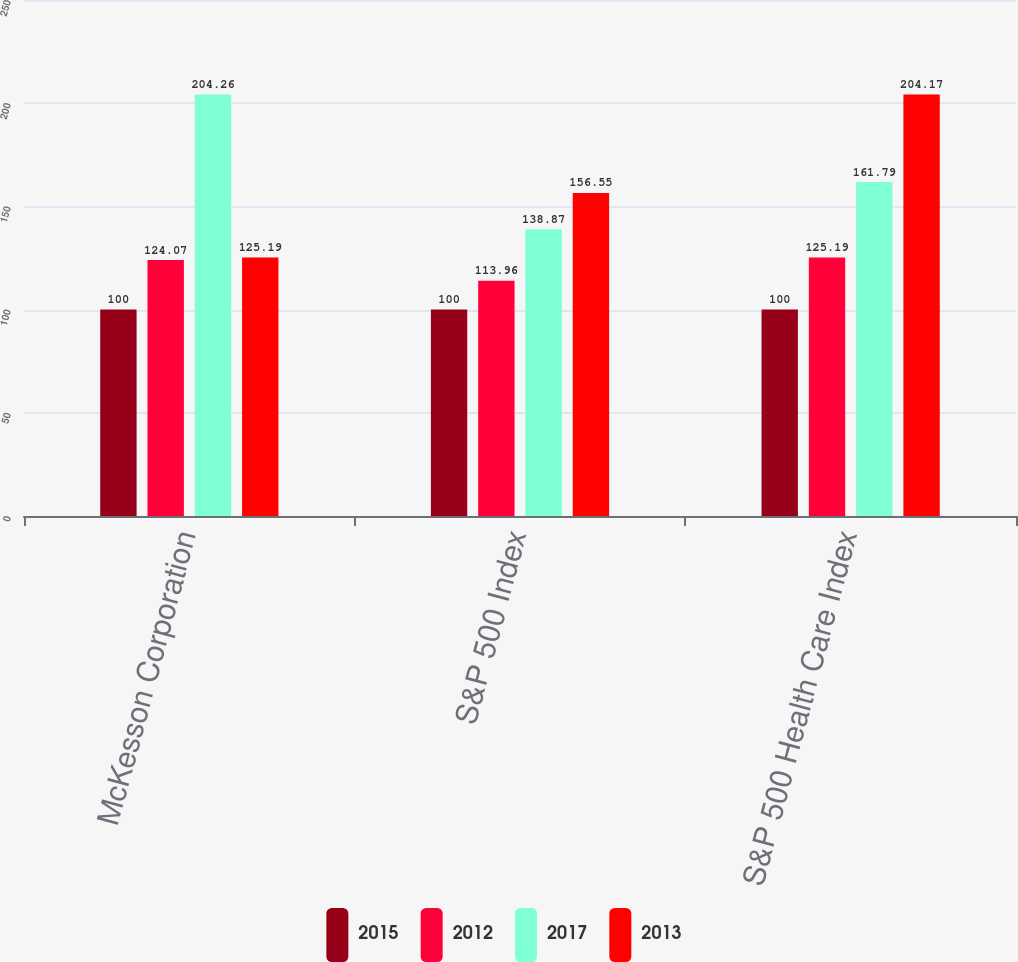<chart> <loc_0><loc_0><loc_500><loc_500><stacked_bar_chart><ecel><fcel>McKesson Corporation<fcel>S&P 500 Index<fcel>S&P 500 Health Care Index<nl><fcel>2015<fcel>100<fcel>100<fcel>100<nl><fcel>2012<fcel>124.07<fcel>113.96<fcel>125.19<nl><fcel>2017<fcel>204.26<fcel>138.87<fcel>161.79<nl><fcel>2013<fcel>125.19<fcel>156.55<fcel>204.17<nl></chart> 